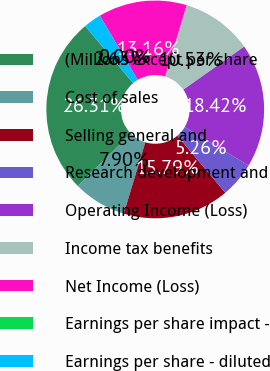<chart> <loc_0><loc_0><loc_500><loc_500><pie_chart><fcel>(Millions except per share<fcel>Cost of sales<fcel>Selling general and<fcel>Research development and<fcel>Operating Income (Loss)<fcel>Income tax benefits<fcel>Net Income (Loss)<fcel>Earnings per share impact -<fcel>Earnings per share - diluted<nl><fcel>26.31%<fcel>7.9%<fcel>15.79%<fcel>5.26%<fcel>18.42%<fcel>10.53%<fcel>13.16%<fcel>0.0%<fcel>2.63%<nl></chart> 